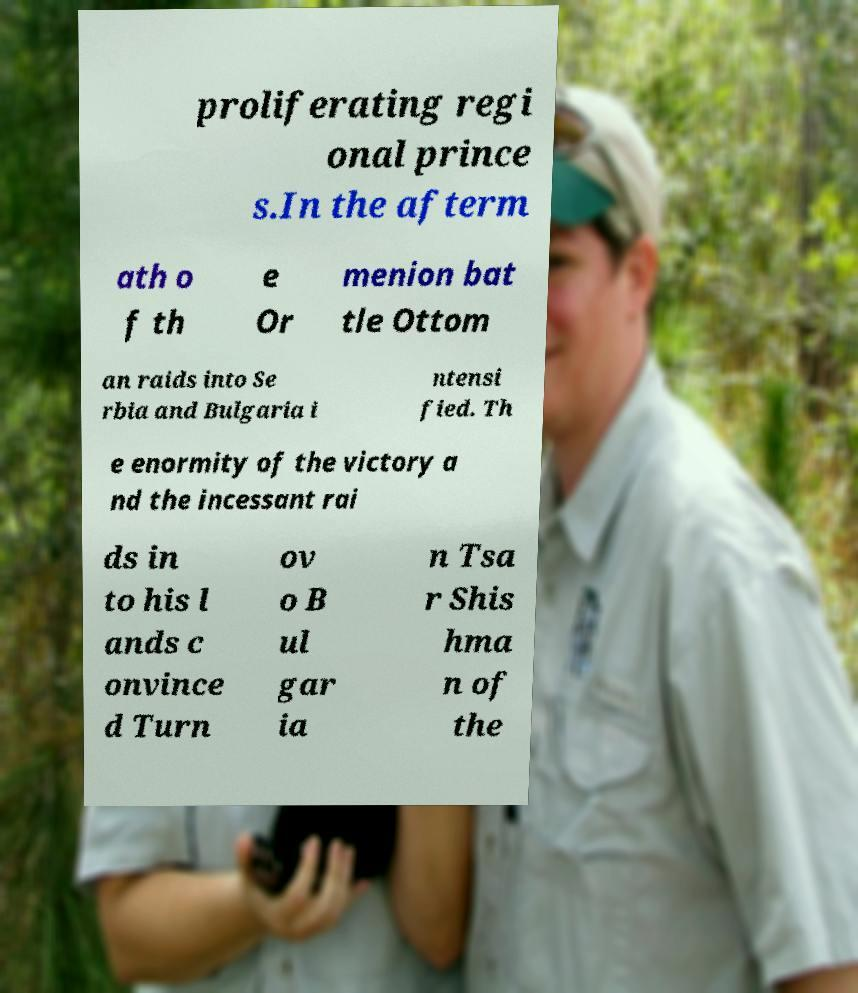There's text embedded in this image that I need extracted. Can you transcribe it verbatim? proliferating regi onal prince s.In the afterm ath o f th e Or menion bat tle Ottom an raids into Se rbia and Bulgaria i ntensi fied. Th e enormity of the victory a nd the incessant rai ds in to his l ands c onvince d Turn ov o B ul gar ia n Tsa r Shis hma n of the 